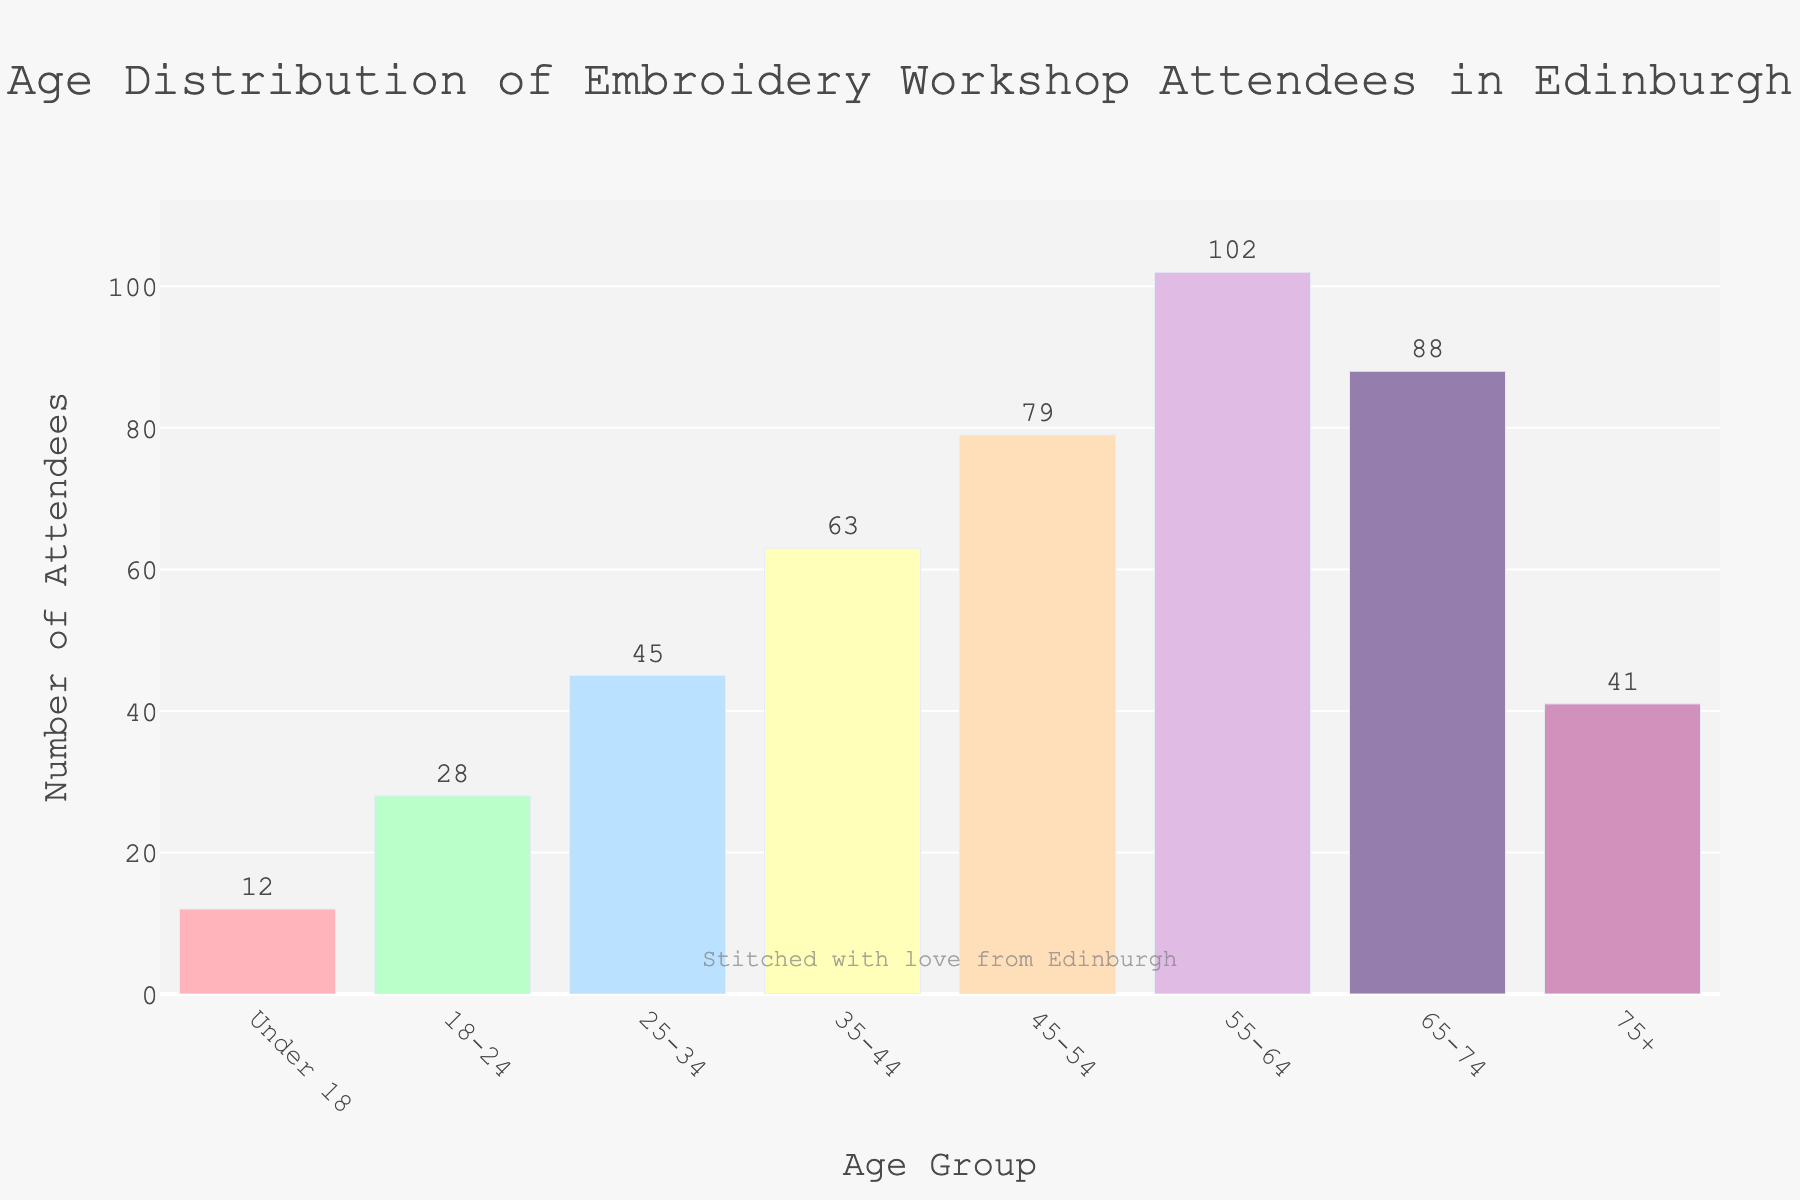Which age group has the highest number of attendees? The bar for the 55-64 age group is the tallest in the chart, indicating that this group has the highest number of attendees.
Answer: 55-64 What is the total number of attendees under 45? Sum the attendees in the "Under 18", "18-24", "25-34", and "35-44" age groups: 12 + 28 + 45 + 63 = 148.
Answer: 148 How many more attendees are there in the 55-64 age group compared to the 75+ age group? Subtract the number of attendees in the 75+ age group from the attendees in the 55-64 age group: 102 - 41 = 61.
Answer: 61 Which two age groups have the closest number of attendees? Compare the bars visually to find the closest heights, noticing that the "65-74" and "75+" age groups are quite close: 88 vs 41. Upon closer inspection, "45-54" and "65-74" are closer: 79 vs 88 with a difference of 9.
Answer: 45-54 and 65-74 What is the average number of attendees per age group? Sum the number of attendees across all groups and divide by the number of groups: (12 + 28 + 45 + 63 + 79 + 102 + 88 + 41) / 8 ≈ 57.25.
Answer: 57.25 Which age group has the second fewest attendees? The "Under 18" age group has the fewest attendees at 12. The second fewest is the "75+" age group with 41 attendees.
Answer: 75+ What is the difference in the number of attendees between the 25-34 and 35-44 age groups? Subtract the number of attendees in the 25-34 age group from the 35-44 age group: 63 - 45 = 18.
Answer: 18 Which age group represents nearly one-fifth of the total number of attendees? Calculate the total number of attendees: 458. Find one-fifth of this value: 458 / 5 = 91.6. The closest number is 88 in the "65-74" age group.
Answer: 65-74 Are there more attendees in the under-25 age groups combined than the 55-64 age group alone? Sum the attendees in "Under 18" and "18-24": 12 + 28 = 40, which is less than 102 from the "55-64" age group.
Answer: No What ratio of attendees are there in the 65-74 age group compared to the 18-24 age group? Divide the number of attendees in the 65-74 age group by the 18-24 age group: 88 / 28 ≈ 3.14.
Answer: 3.14 